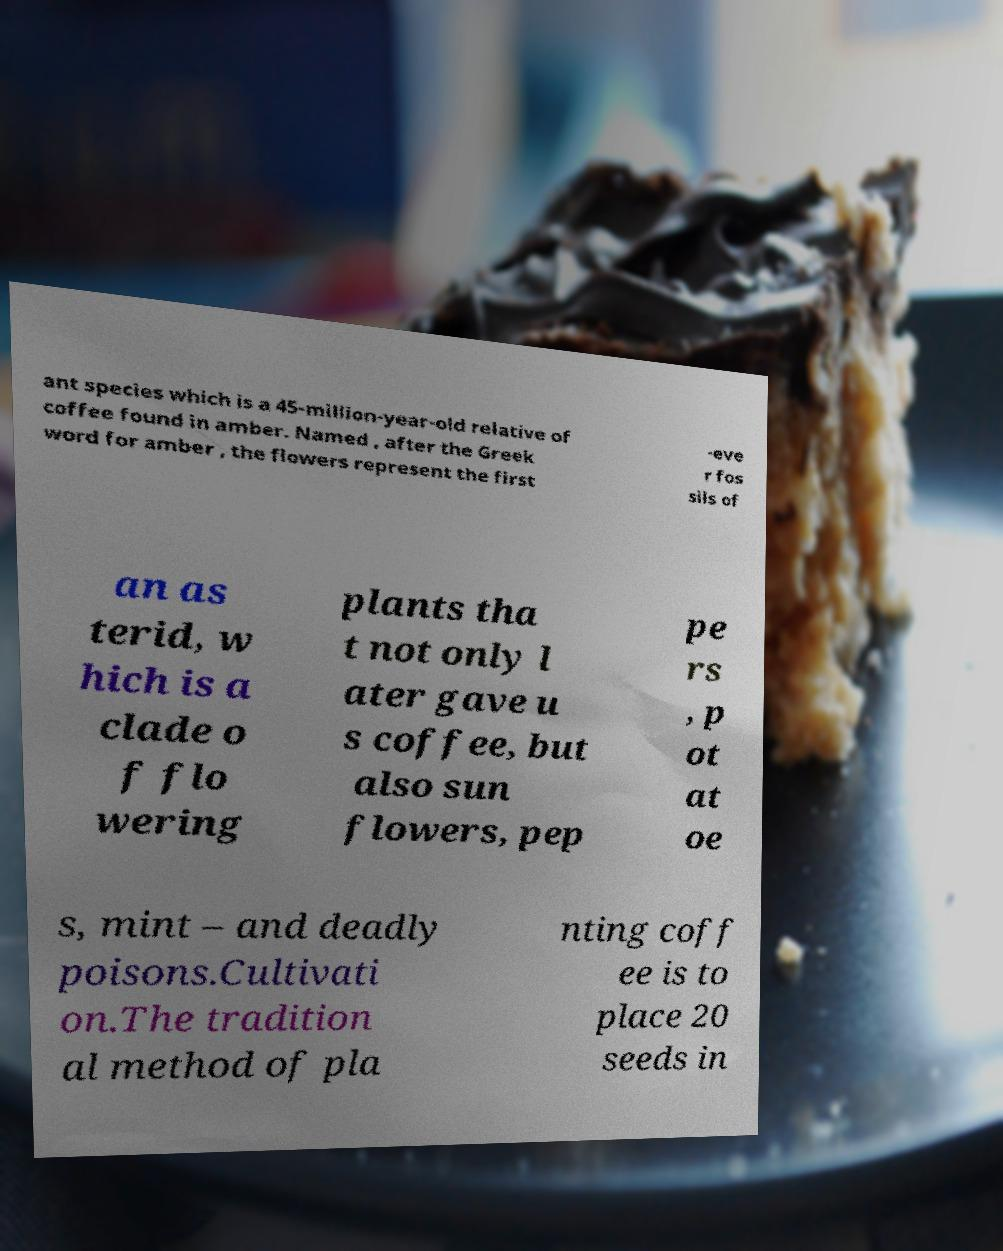Could you extract and type out the text from this image? ant species which is a 45-million-year-old relative of coffee found in amber. Named , after the Greek word for amber , the flowers represent the first -eve r fos sils of an as terid, w hich is a clade o f flo wering plants tha t not only l ater gave u s coffee, but also sun flowers, pep pe rs , p ot at oe s, mint – and deadly poisons.Cultivati on.The tradition al method of pla nting coff ee is to place 20 seeds in 